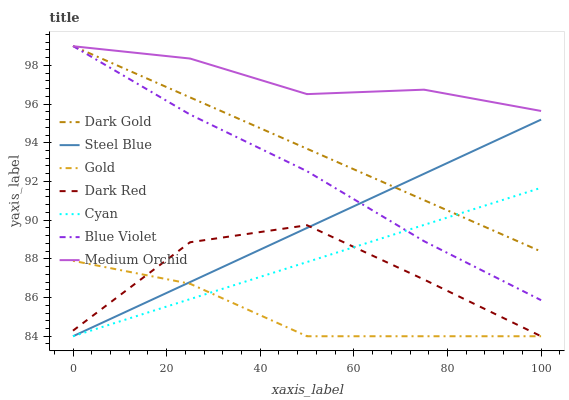Does Gold have the minimum area under the curve?
Answer yes or no. Yes. Does Medium Orchid have the maximum area under the curve?
Answer yes or no. Yes. Does Dark Gold have the minimum area under the curve?
Answer yes or no. No. Does Dark Gold have the maximum area under the curve?
Answer yes or no. No. Is Dark Gold the smoothest?
Answer yes or no. Yes. Is Dark Red the roughest?
Answer yes or no. Yes. Is Dark Red the smoothest?
Answer yes or no. No. Is Dark Gold the roughest?
Answer yes or no. No. Does Gold have the lowest value?
Answer yes or no. Yes. Does Dark Gold have the lowest value?
Answer yes or no. No. Does Blue Violet have the highest value?
Answer yes or no. Yes. Does Dark Red have the highest value?
Answer yes or no. No. Is Gold less than Medium Orchid?
Answer yes or no. Yes. Is Dark Gold greater than Dark Red?
Answer yes or no. Yes. Does Steel Blue intersect Gold?
Answer yes or no. Yes. Is Steel Blue less than Gold?
Answer yes or no. No. Is Steel Blue greater than Gold?
Answer yes or no. No. Does Gold intersect Medium Orchid?
Answer yes or no. No. 